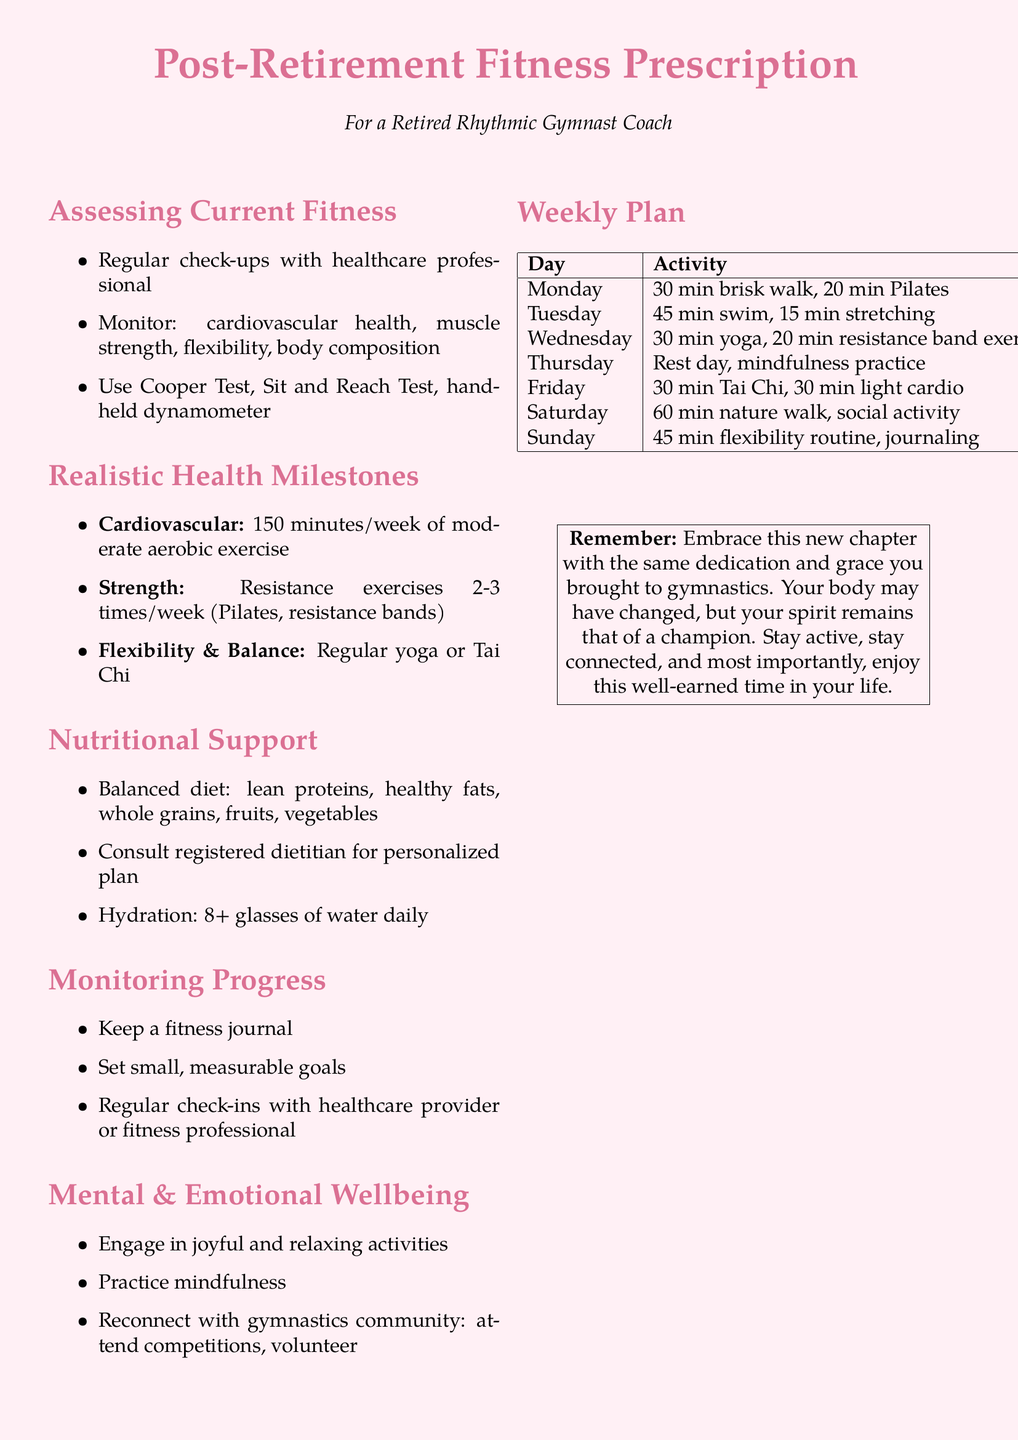What are the four areas monitored for assessing current fitness? The document lists the four areas as cardiovascular health, muscle strength, flexibility, and body composition.
Answer: cardiovascular health, muscle strength, flexibility, body composition How often should strength exercises be performed per week? The document states that resistance exercises should be done 2-3 times per week.
Answer: 2-3 times/week What is the recommended weekly amount of moderate aerobic exercise? The document specifies that 150 minutes per week of moderate aerobic exercise is recommended.
Answer: 150 minutes/week Which activity is suggested for Tuesday? The document lists a 45-minute swim followed by 15 minutes of stretching for Tuesday.
Answer: 45 min swim, 15 min stretching What type of diet is recommended? The document advises a balanced diet including lean proteins, healthy fats, whole grains, fruits, and vegetables.
Answer: balanced diet What should one keep to monitor progress? According to the document, keeping a fitness journal is important for monitoring progress.
Answer: fitness journal What practice is recommended for mental and emotional wellbeing? The document suggests practicing mindfulness as part of mental and emotional wellbeing.
Answer: mindfulness What should you do on your rest day according to the weekly plan? The document indicates that the rest day should include mindfulness practice.
Answer: mindfulness practice 